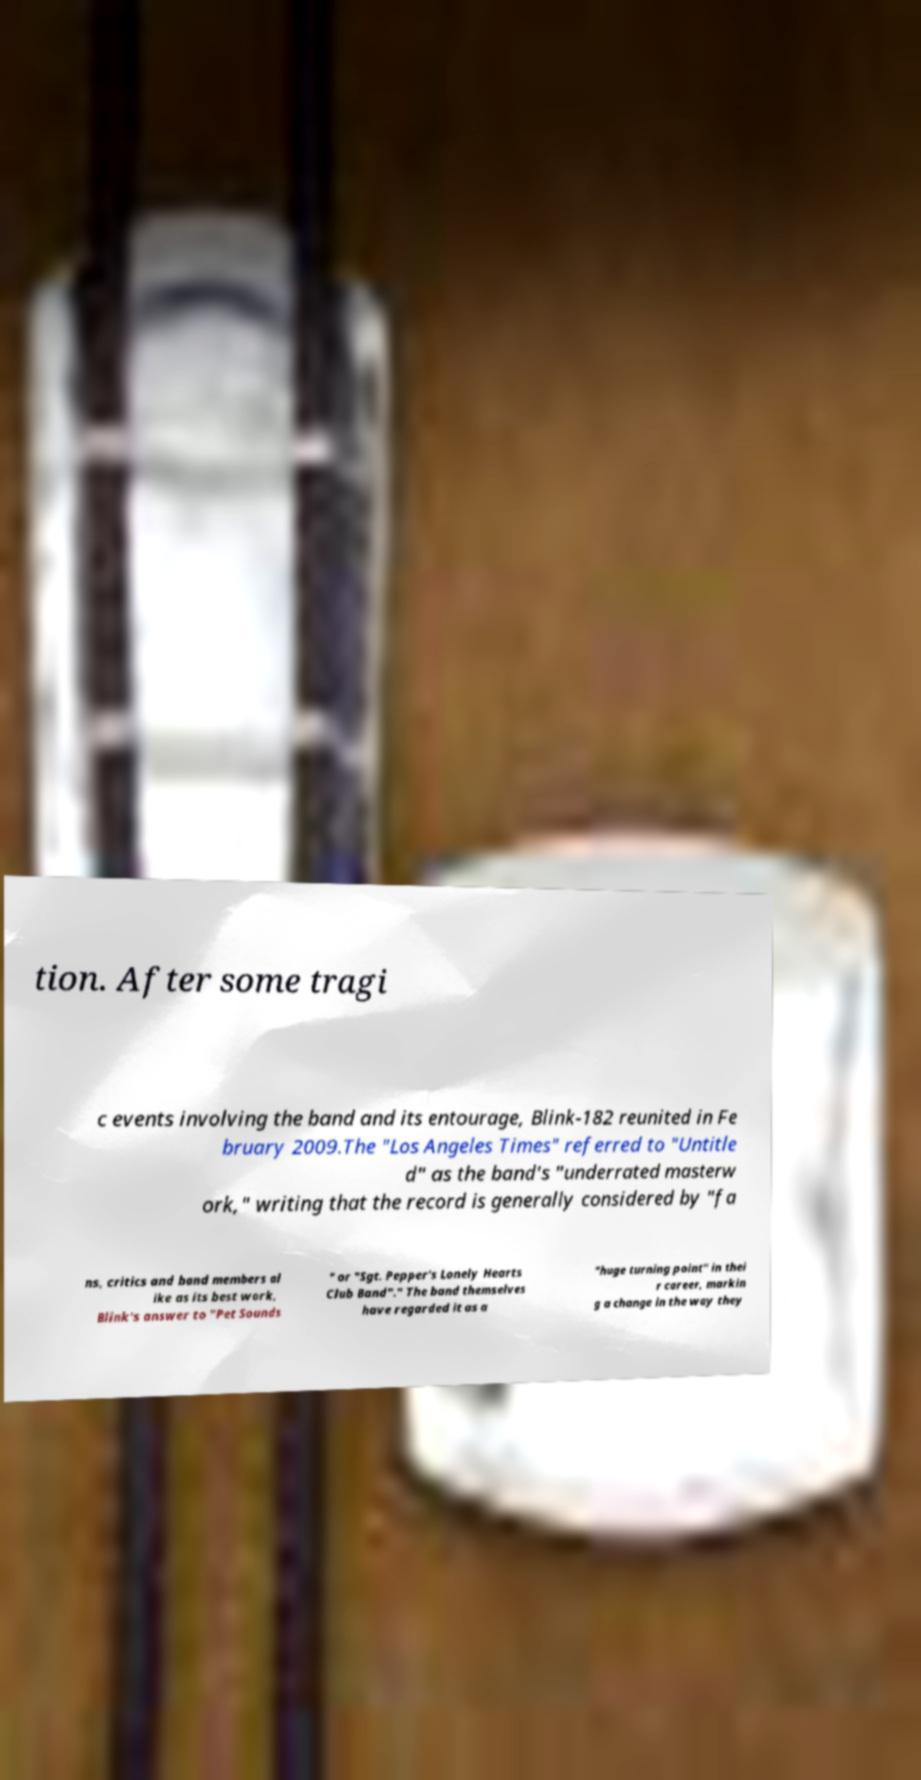What messages or text are displayed in this image? I need them in a readable, typed format. tion. After some tragi c events involving the band and its entourage, Blink-182 reunited in Fe bruary 2009.The "Los Angeles Times" referred to "Untitle d" as the band's "underrated masterw ork," writing that the record is generally considered by "fa ns, critics and band members al ike as its best work, Blink's answer to "Pet Sounds " or "Sgt. Pepper's Lonely Hearts Club Band"." The band themselves have regarded it as a "huge turning point" in thei r career, markin g a change in the way they 